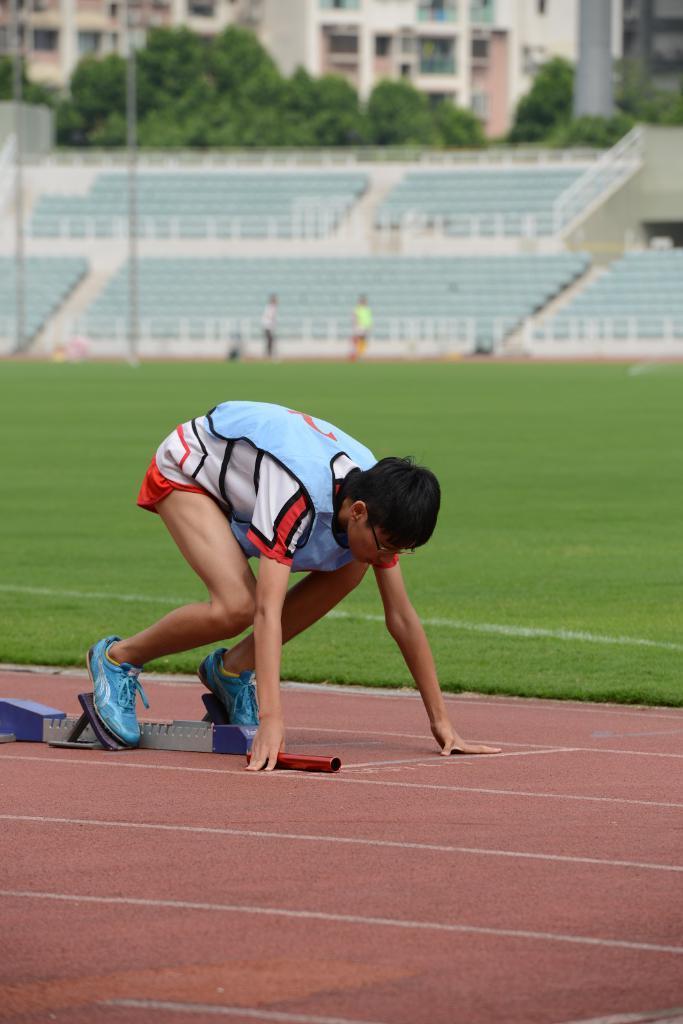Can you describe this image briefly? In the center of the image there is a person on the ground. In the background there are persons, chairs, fencing, building, trees and grass. 